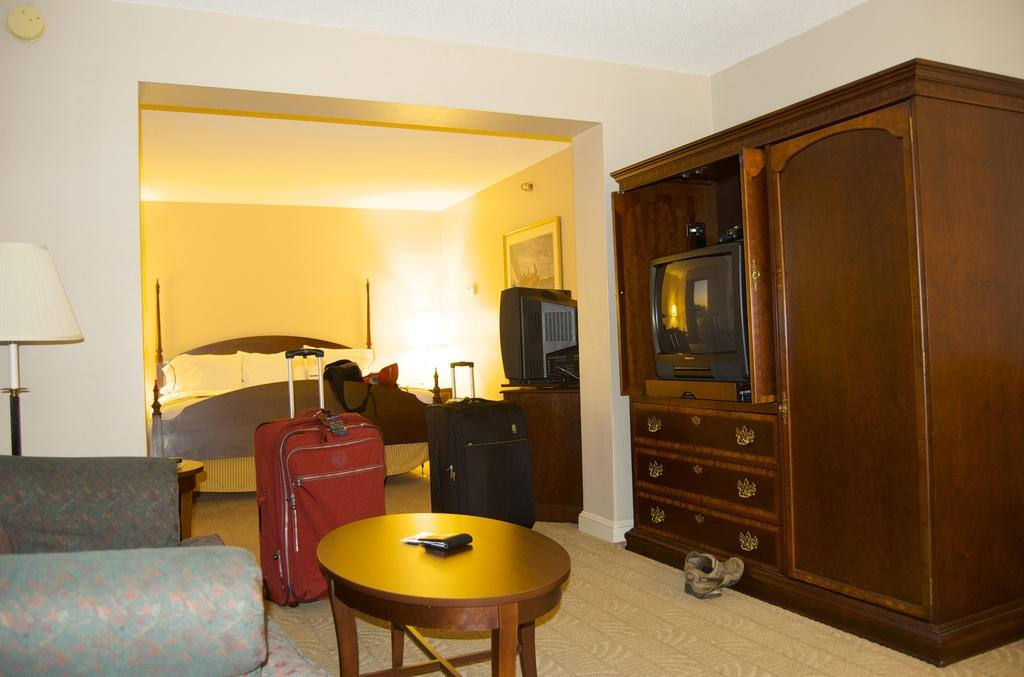What type of electronic device can be found in the room? There is a television in the room. What furniture is present in the room for seating? There is a couch in the room. What is the purpose of the table in the room? The table in the room can be used for various activities, such as placing items or eating. What type of lighting is present in the room? There is a lantern lamp with a stand in the room. What is the sleeping arrangement in the room? There is a bed with pillows in the room. What personal item can be found in the room? There is a wallet in the room. What type of decoration is present on the wall in the room? There is a picture on the wall in the room. What type of bushes can be seen growing in the room? There are no bushes present in the room; the room contains furniture, a television, luggage, a table, a couch, a lantern lamp, a bed, pillows, a wallet, and a picture on the wall. How is the room connected to the internet? The provided facts do not mention any information about the room's internet connection. 